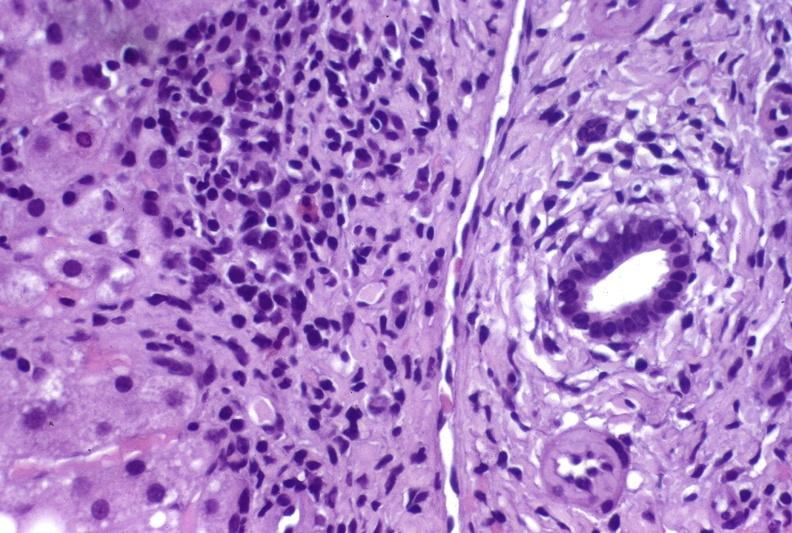what is present?
Answer the question using a single word or phrase. Liver 